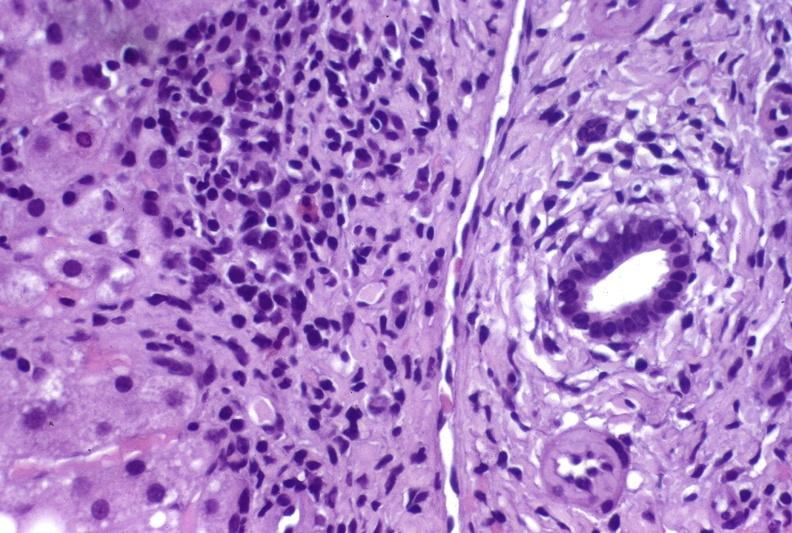what is present?
Answer the question using a single word or phrase. Liver 